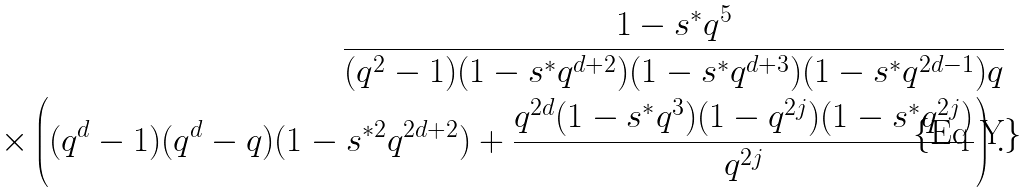<formula> <loc_0><loc_0><loc_500><loc_500>\frac { 1 - s ^ { * } q ^ { 5 } } { ( q ^ { 2 } - 1 ) ( 1 - s ^ { * } q ^ { d + 2 } ) ( 1 - s ^ { * } q ^ { d + 3 } ) ( 1 - s ^ { * } q ^ { 2 d - 1 } ) q } \\ \times \left ( ( q ^ { d } - 1 ) ( q ^ { d } - q ) ( 1 - s ^ { * 2 } q ^ { 2 d + 2 } ) + \frac { q ^ { 2 d } ( 1 - s ^ { * } q ^ { 3 } ) ( 1 - q ^ { 2 j } ) ( 1 - s ^ { * } q ^ { 2 j } ) } { q ^ { 2 j } } \right ) .</formula> 